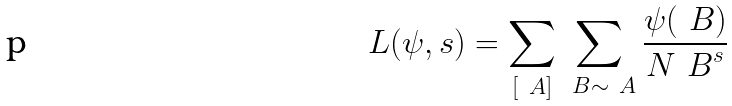Convert formula to latex. <formula><loc_0><loc_0><loc_500><loc_500>L ( \psi , s ) = \sum _ { [ \ A ] } \sum _ { \ B \sim \ A } \frac { \psi ( \ B ) } { { N \ B } ^ { s } }</formula> 